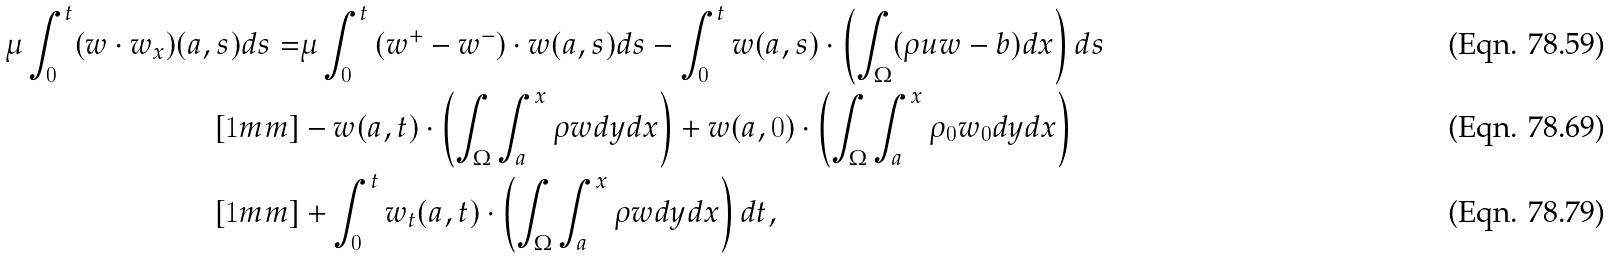Convert formula to latex. <formula><loc_0><loc_0><loc_500><loc_500>\mu \int _ { 0 } ^ { t } ( w \cdot w _ { x } ) ( a , s ) d s = & \mu \int _ { 0 } ^ { t } \left ( w ^ { + } - w ^ { - } \right ) \cdot w ( a , s ) d s - \int _ { 0 } ^ { t } w ( a , s ) \cdot \left ( \int _ { \Omega } ( \rho u w - b ) d x \right ) d s \\ [ 1 m m ] & - w ( a , t ) \cdot \left ( \int _ { \Omega } \int _ { a } ^ { x } \rho w d y d x \right ) + w ( a , 0 ) \cdot \left ( \int _ { \Omega } \int _ { a } ^ { x } \rho _ { 0 } w _ { 0 } d y d x \right ) \\ [ 1 m m ] & + \int _ { 0 } ^ { t } w _ { t } ( a , t ) \cdot \left ( \int _ { \Omega } \int _ { a } ^ { x } \rho w d y d x \right ) d t ,</formula> 